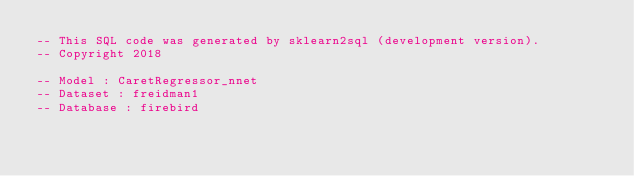Convert code to text. <code><loc_0><loc_0><loc_500><loc_500><_SQL_>-- This SQL code was generated by sklearn2sql (development version).
-- Copyright 2018

-- Model : CaretRegressor_nnet
-- Dataset : freidman1
-- Database : firebird

</code> 